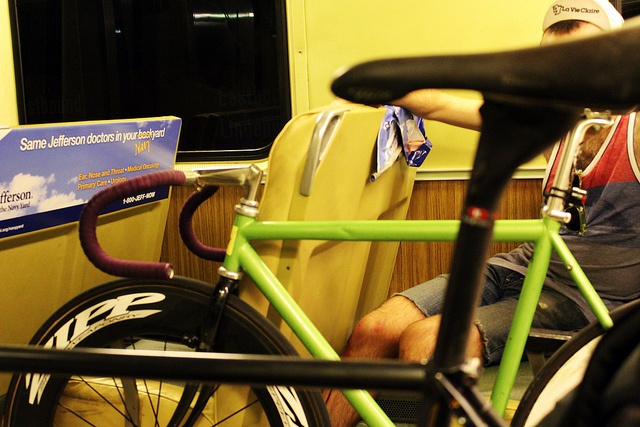Describe the objects in this image and their specific colors. I can see bicycle in khaki, black, maroon, and olive tones, bicycle in khaki, black, olive, and orange tones, tv in khaki, black, and olive tones, chair in khaki, orange, olive, and gold tones, and people in khaki, black, maroon, and brown tones in this image. 